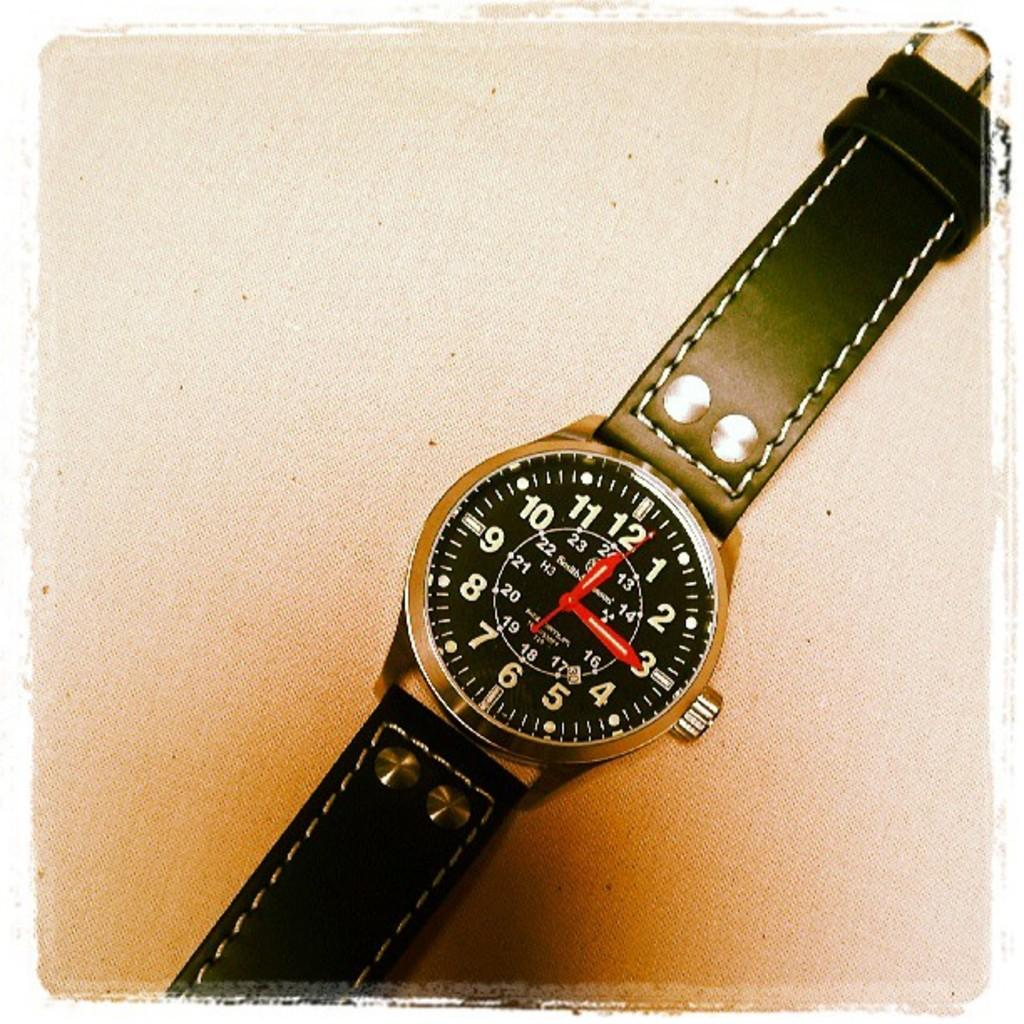<image>
Offer a succinct explanation of the picture presented. A black watch has a small "H3" label on the face near the 9. 